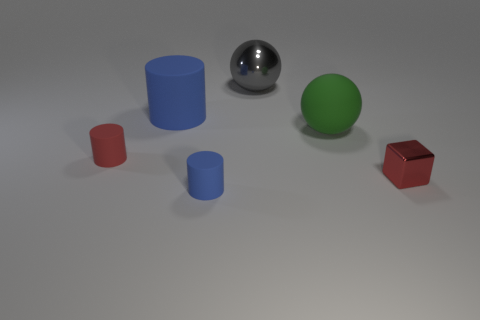What color is the matte object that is the same shape as the big gray metallic object?
Keep it short and to the point. Green. Does the big gray object have the same shape as the green object?
Provide a succinct answer. Yes. There is a gray metallic object that is the same shape as the large green rubber object; what size is it?
Make the answer very short. Large. What number of red objects are the same material as the large blue thing?
Offer a terse response. 1. How many objects are either big matte objects or small blue cylinders?
Offer a very short reply. 3. There is a red thing that is behind the tiny block; are there any green balls right of it?
Keep it short and to the point. Yes. Is the number of blue things that are behind the red cylinder greater than the number of big green matte spheres to the left of the green matte object?
Your response must be concise. Yes. There is a tiny cylinder that is the same color as the large cylinder; what material is it?
Make the answer very short. Rubber. How many things have the same color as the small metallic block?
Keep it short and to the point. 1. Does the large rubber thing that is to the left of the green sphere have the same color as the cylinder that is on the right side of the big blue rubber object?
Keep it short and to the point. Yes. 